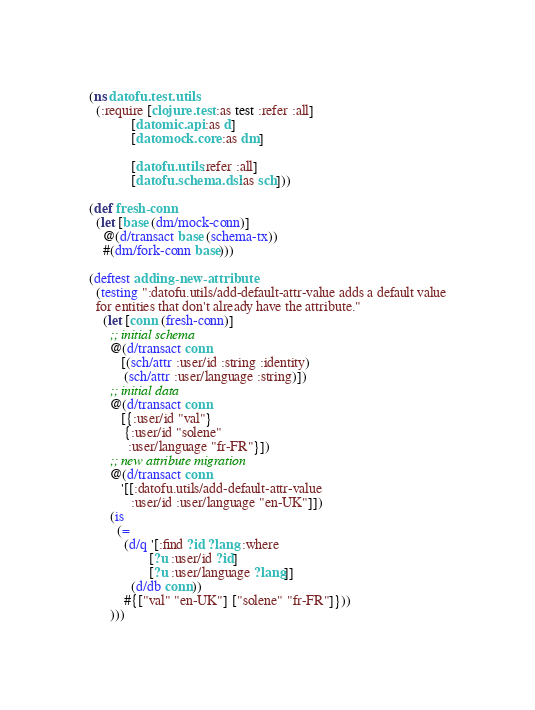<code> <loc_0><loc_0><loc_500><loc_500><_Clojure_>(ns datofu.test.utils
  (:require [clojure.test :as test :refer :all]
            [datomic.api :as d]
            [datomock.core :as dm]

            [datofu.utils :refer :all]
            [datofu.schema.dsl :as sch]))

(def fresh-conn
  (let [base (dm/mock-conn)]
    @(d/transact base (schema-tx))
    #(dm/fork-conn base)))

(deftest adding-new-attribute
  (testing ":datofu.utils/add-default-attr-value adds a default value
  for entities that don't already have the attribute."
    (let [conn (fresh-conn)]
      ;; initial schema
      @(d/transact conn
         [(sch/attr :user/id :string :identity)
          (sch/attr :user/language :string)])
      ;; initial data
      @(d/transact conn
         [{:user/id "val"}
          {:user/id "solene"
           :user/language "fr-FR"}])
      ;; new attribute migration
      @(d/transact conn
         '[[:datofu.utils/add-default-attr-value
            :user/id :user/language "en-UK"]])
      (is
        (=
          (d/q '[:find ?id ?lang :where
                 [?u :user/id ?id]
                 [?u :user/language ?lang]]
            (d/db conn))
          #{["val" "en-UK"] ["solene" "fr-FR"]}))
      )))
</code> 